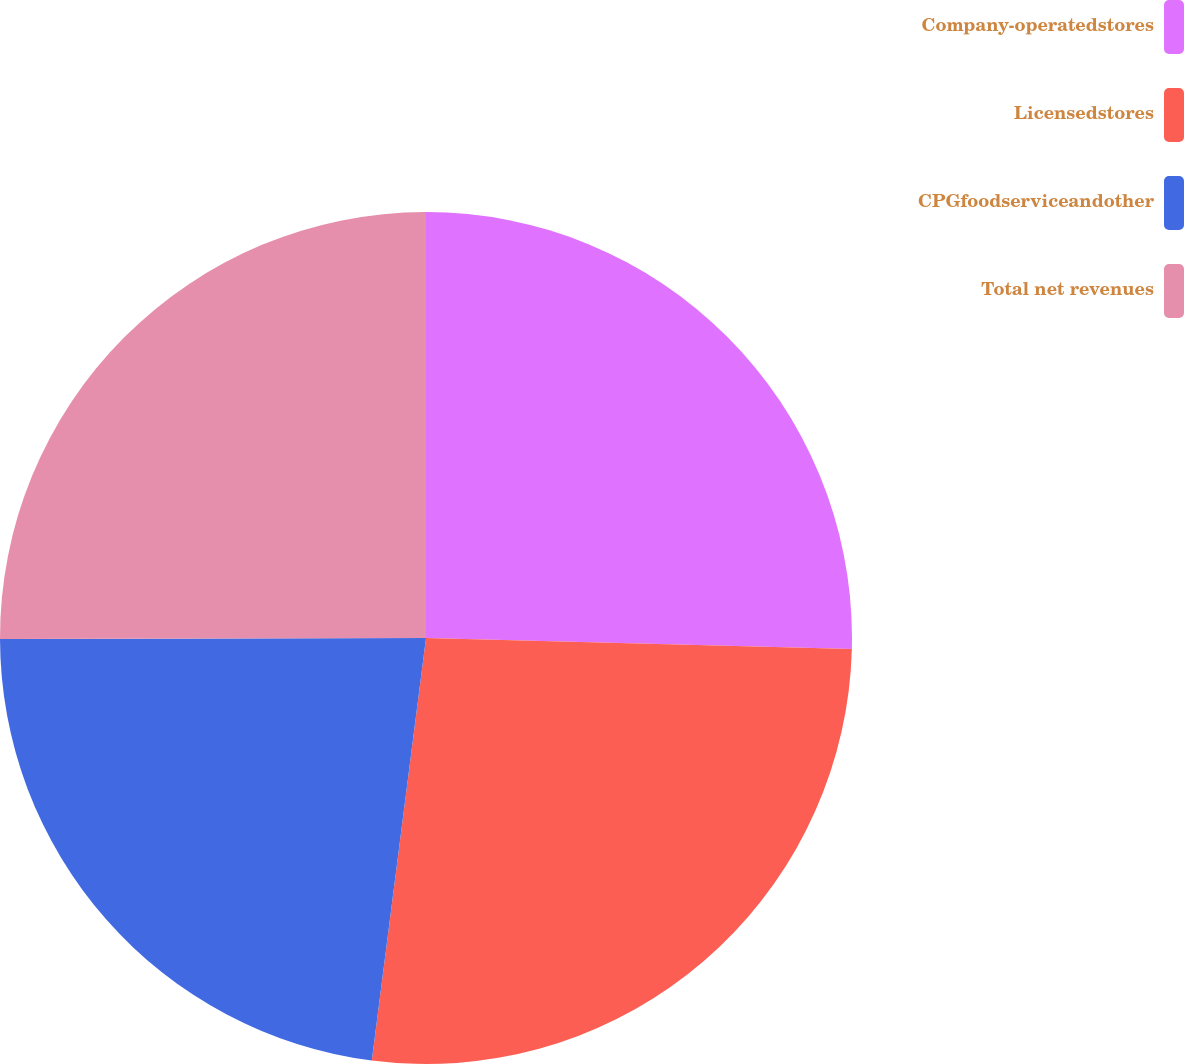<chart> <loc_0><loc_0><loc_500><loc_500><pie_chart><fcel>Company-operatedstores<fcel>Licensedstores<fcel>CPGfoodserviceandother<fcel>Total net revenues<nl><fcel>25.41%<fcel>26.62%<fcel>22.93%<fcel>25.04%<nl></chart> 